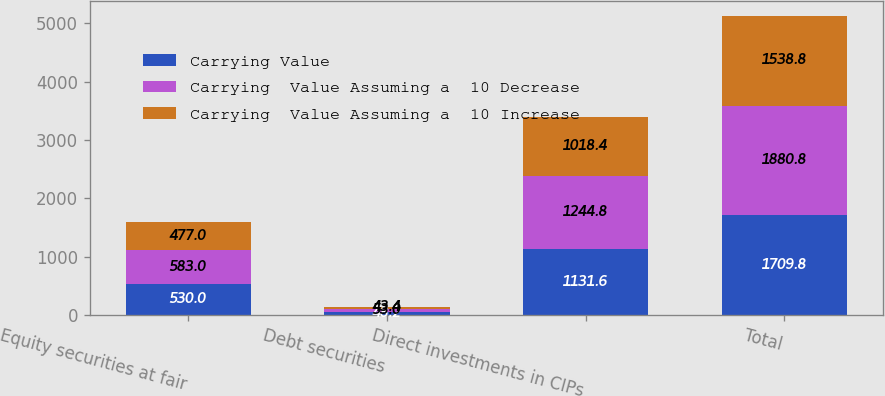<chart> <loc_0><loc_0><loc_500><loc_500><stacked_bar_chart><ecel><fcel>Equity securities at fair<fcel>Debt securities<fcel>Direct investments in CIPs<fcel>Total<nl><fcel>Carrying Value<fcel>530<fcel>48.2<fcel>1131.6<fcel>1709.8<nl><fcel>Carrying  Value Assuming a  10 Decrease<fcel>583<fcel>53<fcel>1244.8<fcel>1880.8<nl><fcel>Carrying  Value Assuming a  10 Increase<fcel>477<fcel>43.4<fcel>1018.4<fcel>1538.8<nl></chart> 